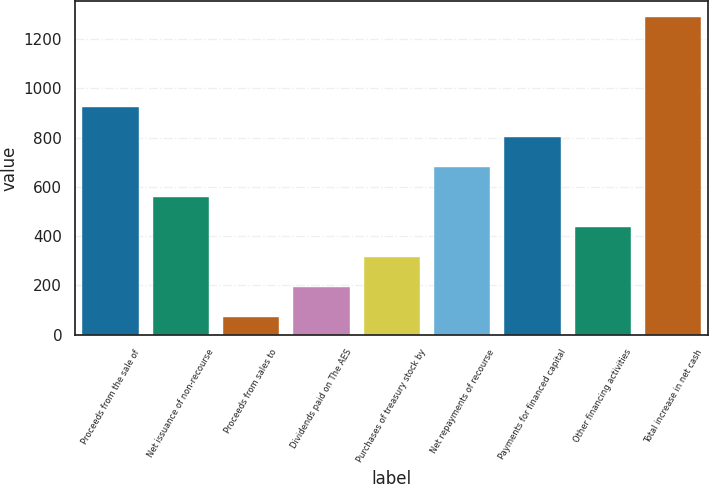Convert chart. <chart><loc_0><loc_0><loc_500><loc_500><bar_chart><fcel>Proceeds from the sale of<fcel>Net issuance of non-recourse<fcel>Proceeds from sales to<fcel>Dividends paid on The AES<fcel>Purchases of treasury stock by<fcel>Net repayments of recourse<fcel>Payments for financed capital<fcel>Other financing activities<fcel>Total increase in net cash<nl><fcel>924.3<fcel>558.6<fcel>71<fcel>192.9<fcel>314.8<fcel>680.5<fcel>802.4<fcel>436.7<fcel>1290<nl></chart> 